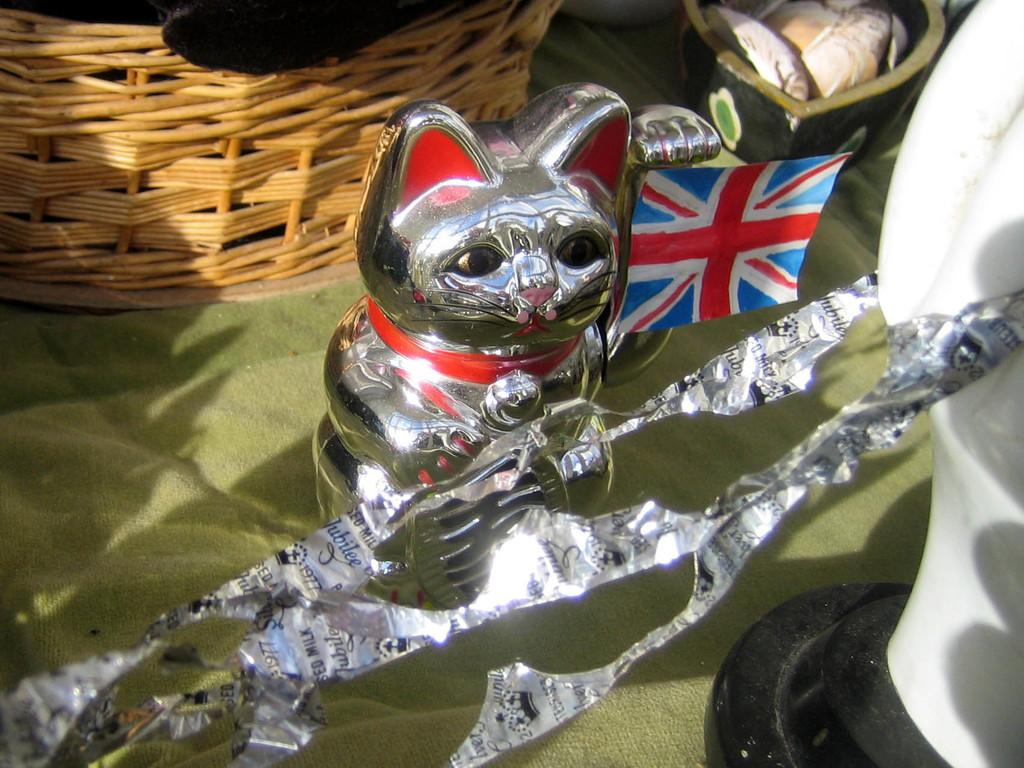What type of object can be seen in the image? There is a toy in the image. What is the toy placed in or on? There is a basket in the image. What is covering the objects in the image? There are objects on a cloth in the image. What type of tax is being discussed in the image? There is no mention of tax in the image; it features a toy, a basket, and objects on a cloth. Can you see any popcorn in the image? There is no popcorn present in the image. 